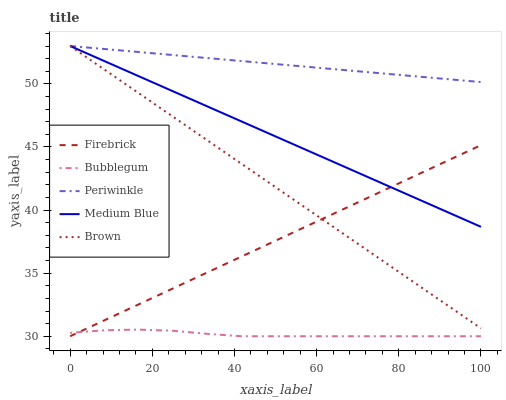Does Bubblegum have the minimum area under the curve?
Answer yes or no. Yes. Does Periwinkle have the maximum area under the curve?
Answer yes or no. Yes. Does Firebrick have the minimum area under the curve?
Answer yes or no. No. Does Firebrick have the maximum area under the curve?
Answer yes or no. No. Is Firebrick the smoothest?
Answer yes or no. Yes. Is Bubblegum the roughest?
Answer yes or no. Yes. Is Periwinkle the smoothest?
Answer yes or no. No. Is Periwinkle the roughest?
Answer yes or no. No. Does Firebrick have the lowest value?
Answer yes or no. Yes. Does Periwinkle have the lowest value?
Answer yes or no. No. Does Brown have the highest value?
Answer yes or no. Yes. Does Firebrick have the highest value?
Answer yes or no. No. Is Bubblegum less than Brown?
Answer yes or no. Yes. Is Periwinkle greater than Firebrick?
Answer yes or no. Yes. Does Brown intersect Periwinkle?
Answer yes or no. Yes. Is Brown less than Periwinkle?
Answer yes or no. No. Is Brown greater than Periwinkle?
Answer yes or no. No. Does Bubblegum intersect Brown?
Answer yes or no. No. 